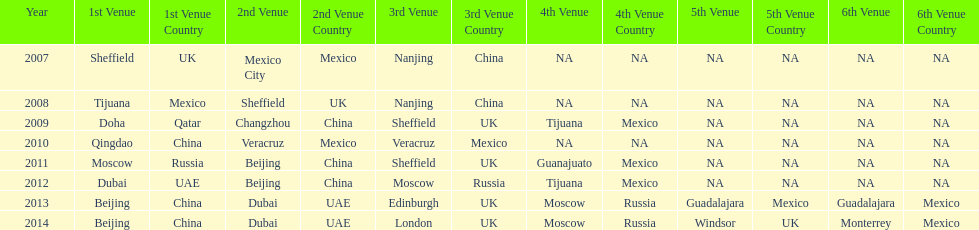How long, in years, has the this world series been occurring? 7 years. 